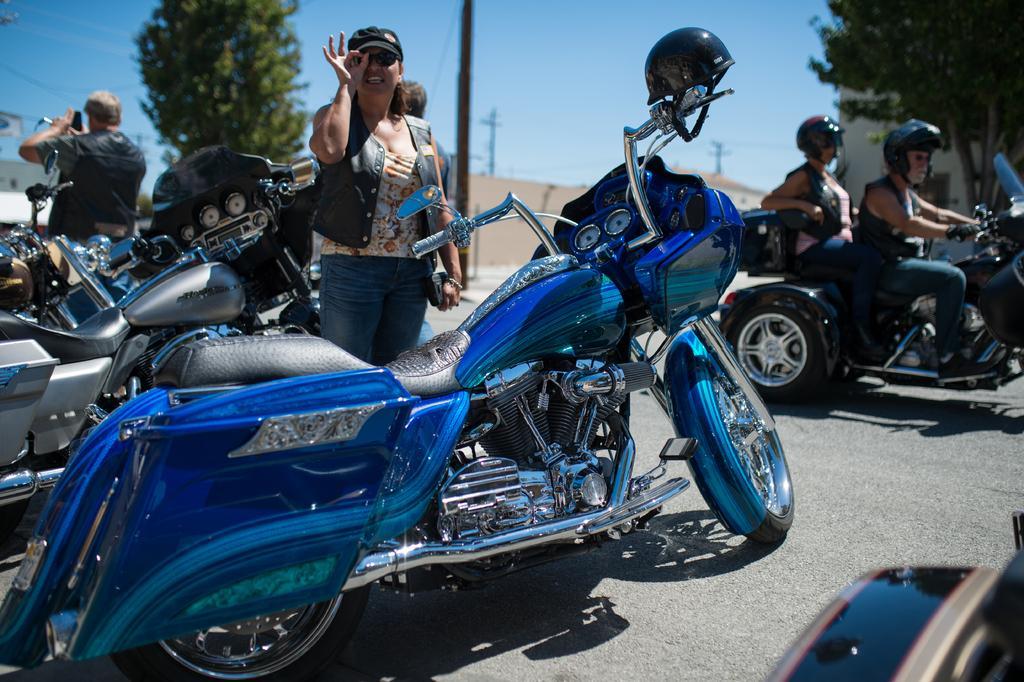Describe this image in one or two sentences. These are motorbikes. These two persons are sitting on his motorbike. This woman is standing and wore cap. Far there are trees. This man is standing and holding a mobile. 